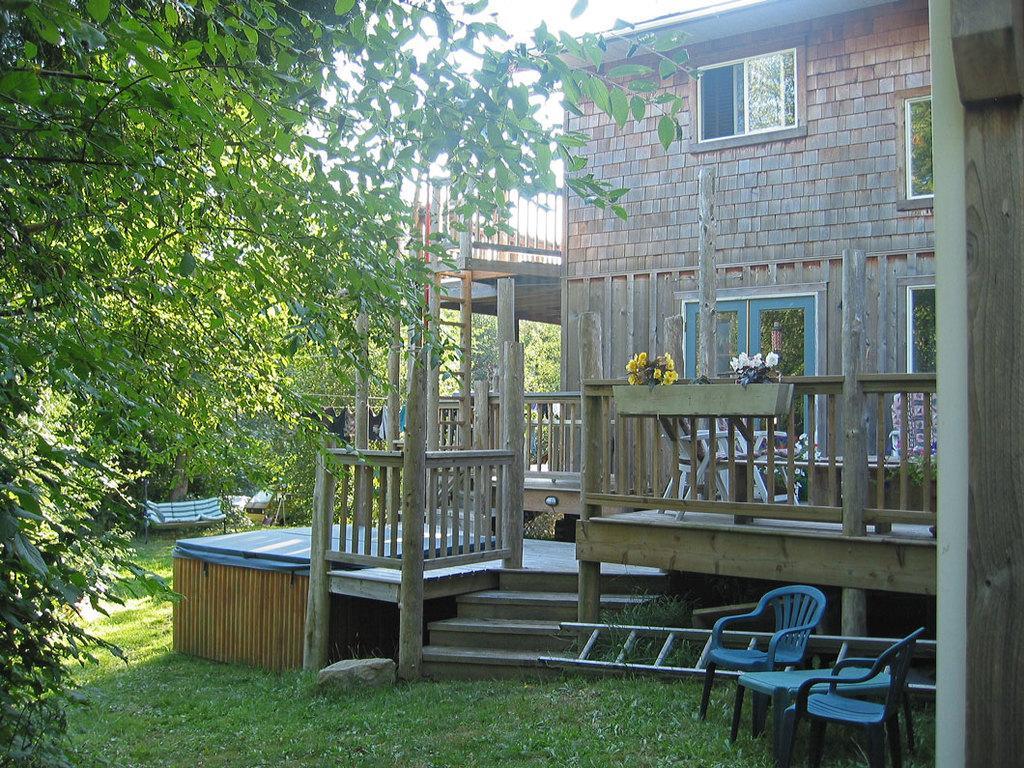How would you summarize this image in a sentence or two? Here we can see grass, chairs, ladder, plants, flowers, bench, trees, and a building. In the background there is sky. 